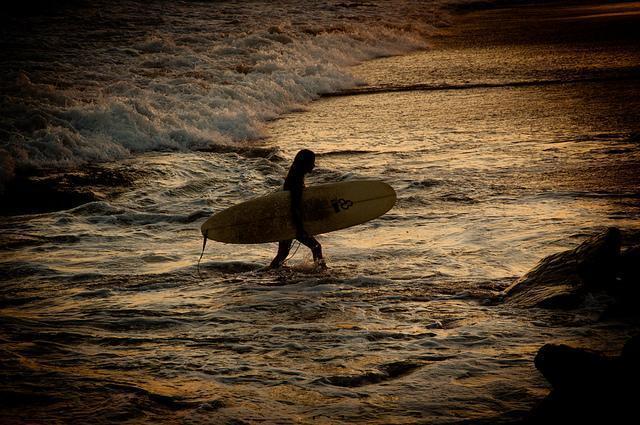How many people can you see?
Give a very brief answer. 1. 